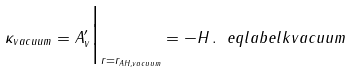Convert formula to latex. <formula><loc_0><loc_0><loc_500><loc_500>\kappa _ { v a c u u m } = A _ { v } ^ { \prime } \Big | _ { r = r _ { A H , v a c u u m } } = - H \, . \ e q l a b e l { k v a c u u m }</formula> 